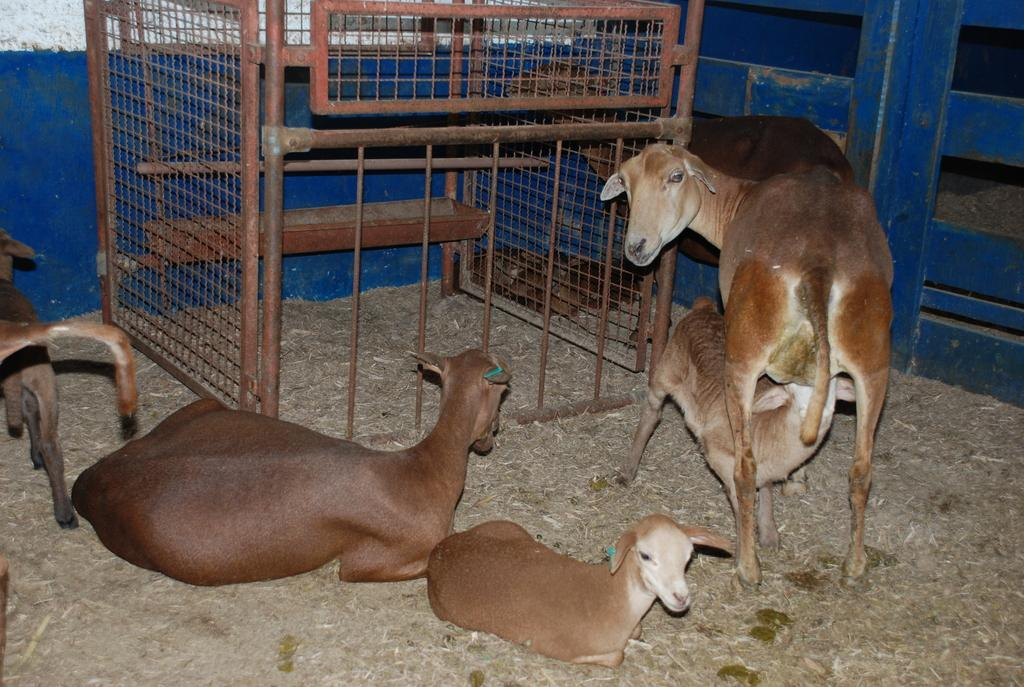What animals are present on the ground in the image? There are goats on the ground in the image. What type of structure can be seen in the image? There is an iron structure in the image. What is used to enclose or separate areas in the image? There are fences in the image. What does the caption say about the goats in the image? There is no caption present in the image, so it is not possible to determine what it might say about the goats. 